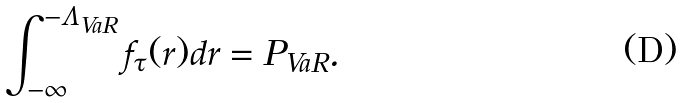Convert formula to latex. <formula><loc_0><loc_0><loc_500><loc_500>\int _ { - \infty } ^ { - \Lambda _ { V a R } } f _ { \tau } ( r ) d r = P _ { V a R } .</formula> 